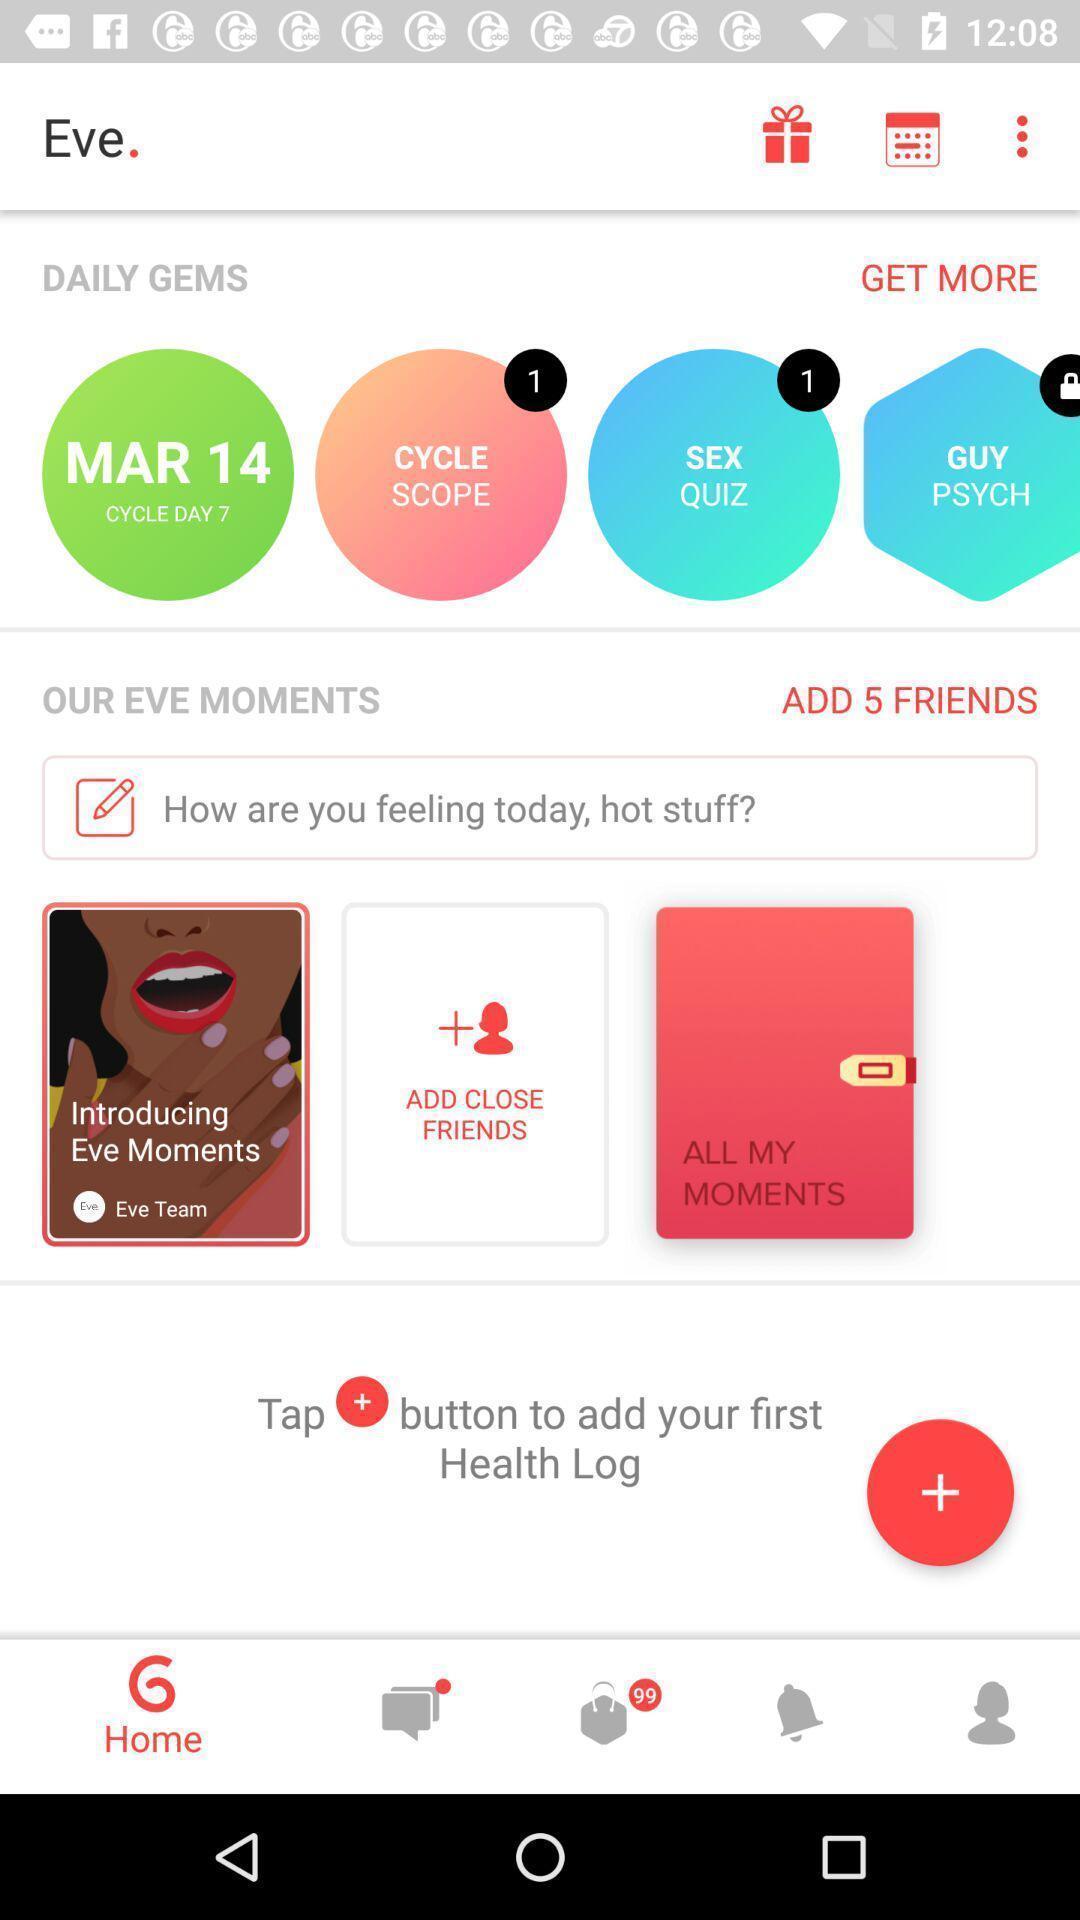Tell me about the visual elements in this screen capture. Screen displaying multiple controls in a menstrual tracking application. 